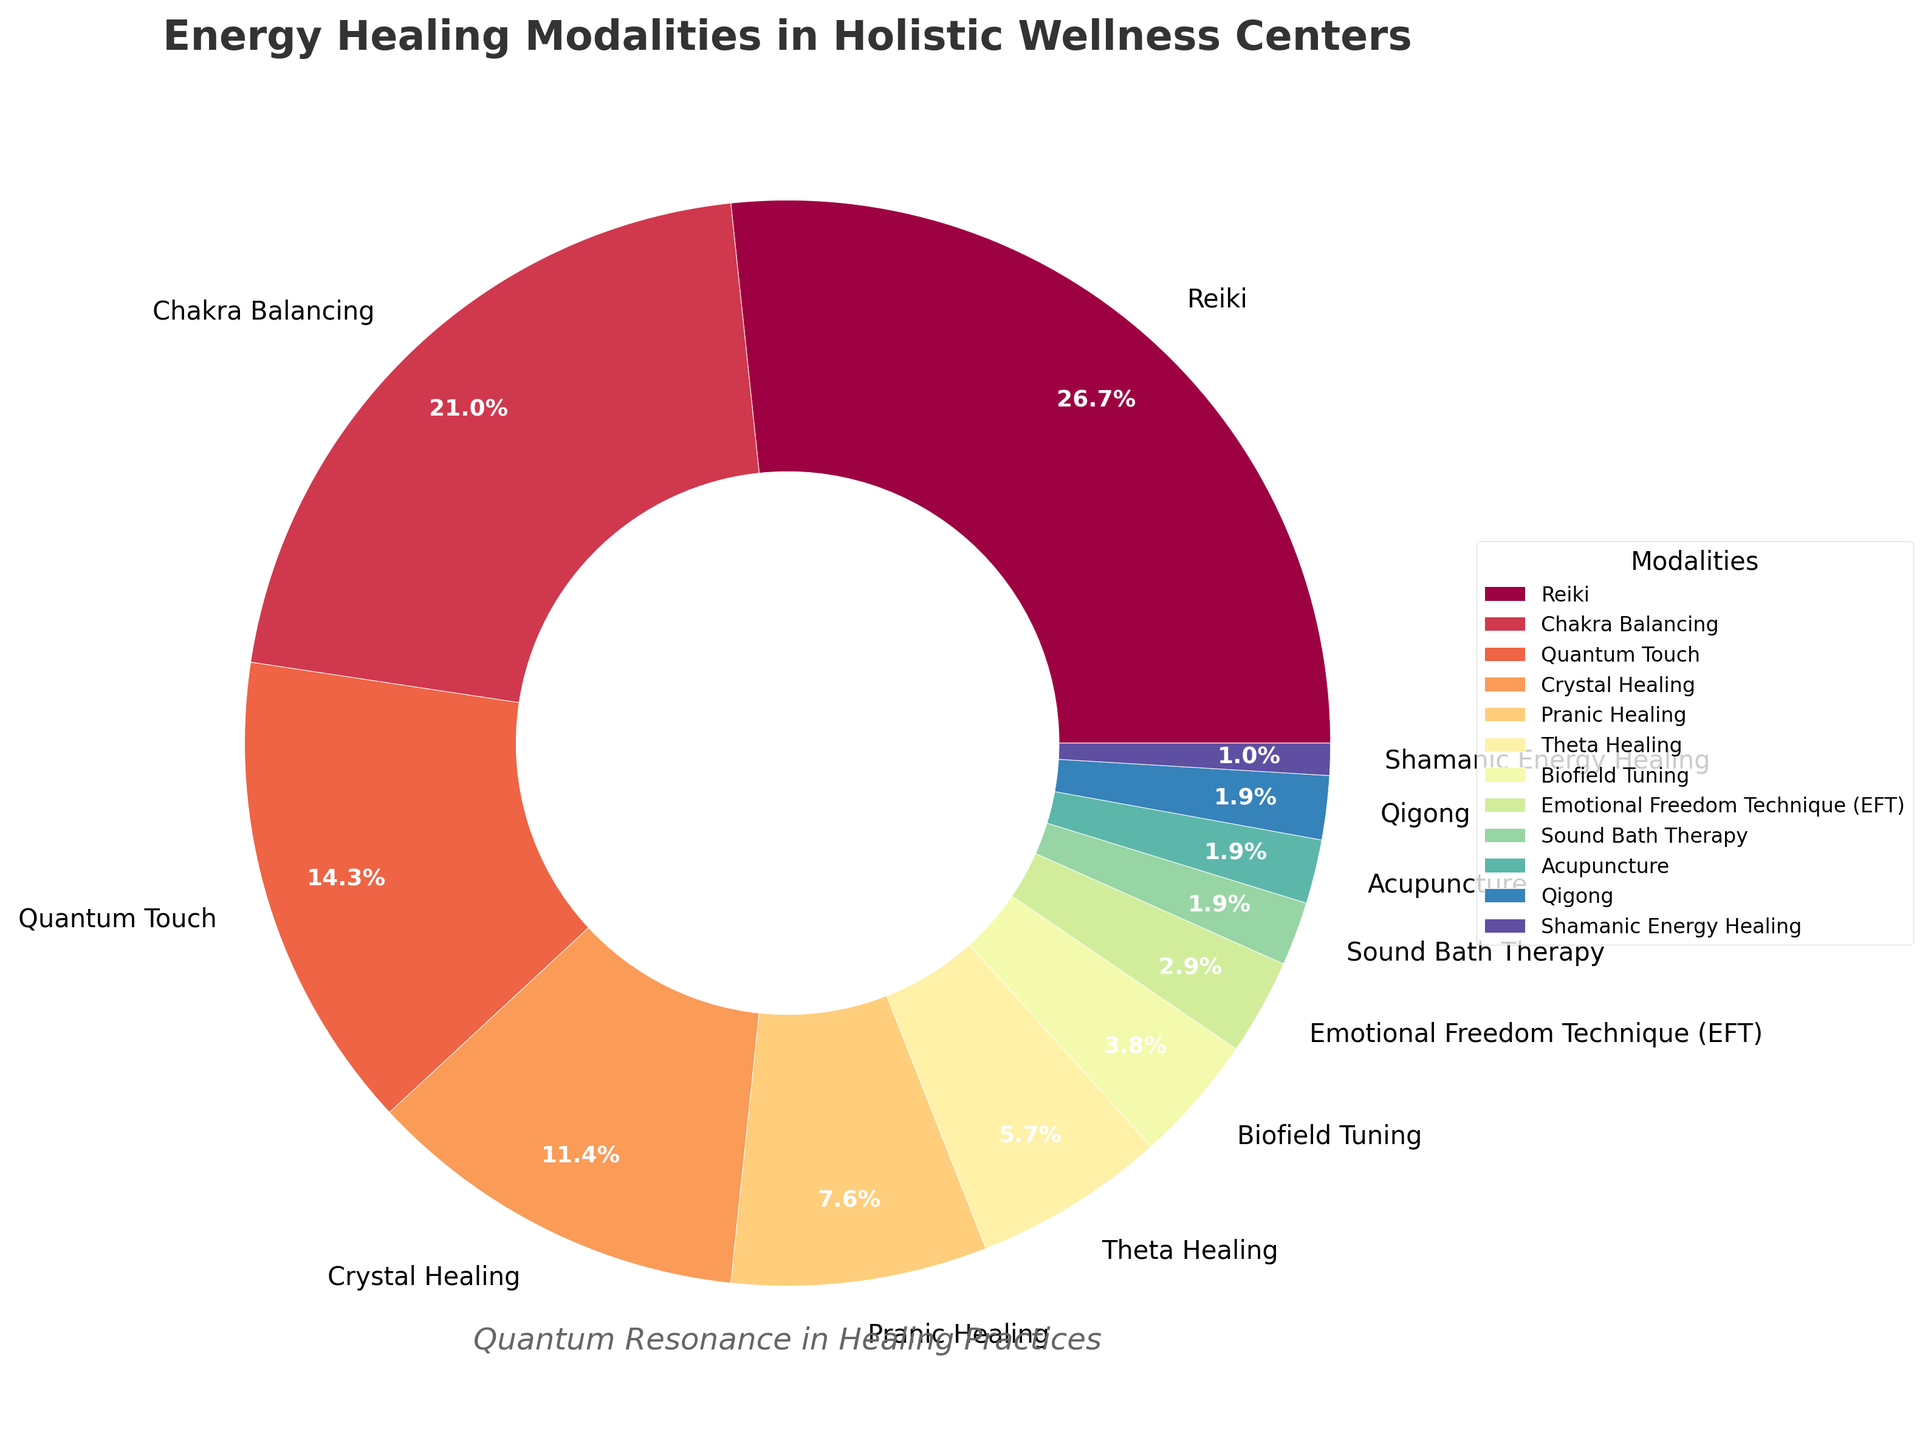Which modality has the highest percentage? By referring to the figure, Reiki has the largest section in the pie chart, indicating it holds the highest percentage among all modalities.
Answer: Reiki Which modality has the lowest percentage? The smallest section in the pie chart corresponds to Shamanic Energy Healing, showing it has the lowest percentage.
Answer: Shamanic Energy Healing What are the combined percentages of Quantum Touch and Crystal Healing? Sum the percentages of both Quantum Touch (15%) and Crystal Healing (12%), resulting in 27%.
Answer: 27% Is Theta Healing used more frequently than Biofield Tuning? By comparing their respective sections, Theta Healing has a larger percentage (6%) than Biofield Tuning (4%).
Answer: Yes Which modality comprises exactly 8% of the total? Pranic Healing has a section labeled with 8%, indicating it comprises this percentage.
Answer: Pranic Healing What is the percentage difference between Chakra Balancing and Sound Bath Therapy? Calculate the difference: Chakra Balancing (22%) minus Sound Bath Therapy (2%) gives 20%.
Answer: 20% Are Acupuncture and Qigong used equally? Both Acupuncture and Qigong have sections labeled with 2%, showing they are used equally.
Answer: Yes What is the combined percentage of all modalities that have over 10% each? Sum the percentages of Reiki (28%), Chakra Balancing (22%), Quantum Touch (15%), and Crystal Healing (12%): 28% + 22% + 15% + 12% = 77%.
Answer: 77% Which modality is represented with the third largest percentage? Reiki is the largest, followed by Chakra Balancing, and then Quantum Touch at 15%.
Answer: Quantum Touch What is the total percentage of the least three modalities? Sum the percentages of the least three: Shamanic Energy Healing (1%), Qigong (2%), and Acupuncture (2%): 1% + 2% + 2% = 5%.
Answer: 5% 